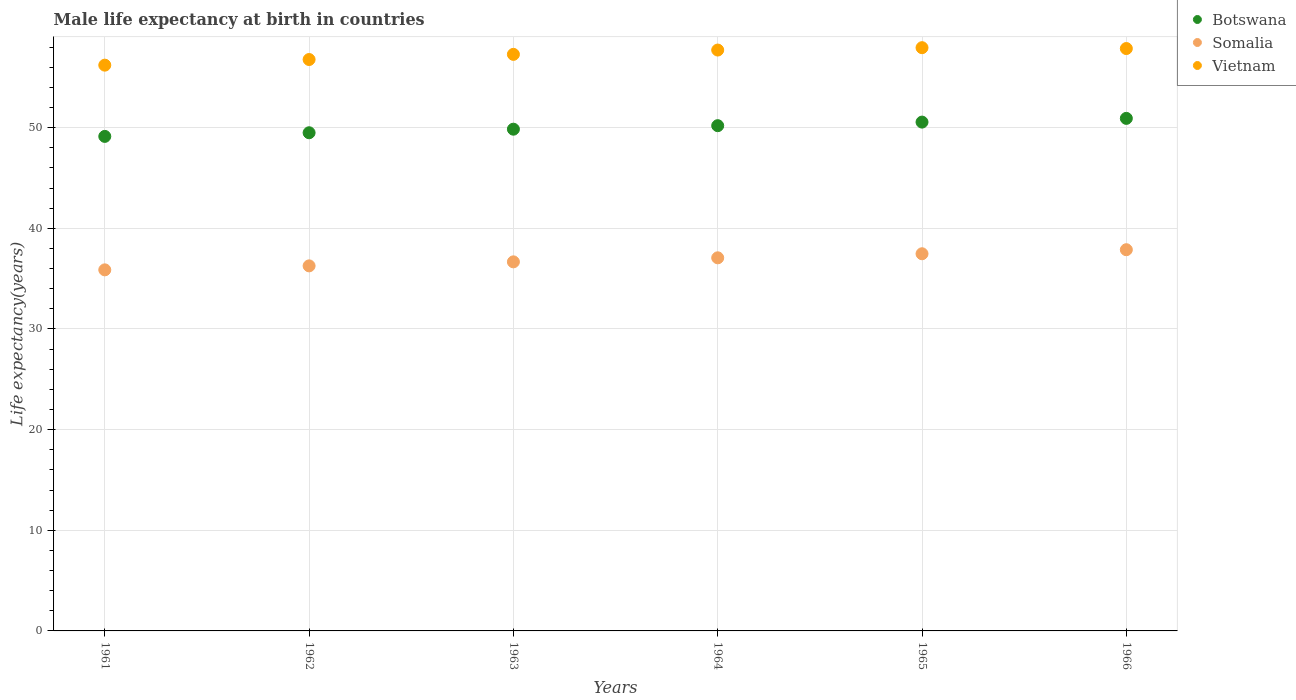What is the male life expectancy at birth in Vietnam in 1966?
Your answer should be very brief. 57.86. Across all years, what is the maximum male life expectancy at birth in Vietnam?
Provide a short and direct response. 57.95. Across all years, what is the minimum male life expectancy at birth in Vietnam?
Provide a succinct answer. 56.21. In which year was the male life expectancy at birth in Somalia maximum?
Provide a short and direct response. 1966. In which year was the male life expectancy at birth in Vietnam minimum?
Your answer should be compact. 1961. What is the total male life expectancy at birth in Somalia in the graph?
Provide a short and direct response. 221.23. What is the difference between the male life expectancy at birth in Somalia in 1961 and that in 1962?
Your answer should be very brief. -0.4. What is the difference between the male life expectancy at birth in Botswana in 1966 and the male life expectancy at birth in Vietnam in 1964?
Provide a succinct answer. -6.79. What is the average male life expectancy at birth in Botswana per year?
Give a very brief answer. 50.03. In the year 1963, what is the difference between the male life expectancy at birth in Vietnam and male life expectancy at birth in Somalia?
Provide a short and direct response. 20.62. What is the ratio of the male life expectancy at birth in Botswana in 1963 to that in 1966?
Make the answer very short. 0.98. Is the male life expectancy at birth in Somalia in 1964 less than that in 1966?
Give a very brief answer. Yes. What is the difference between the highest and the second highest male life expectancy at birth in Vietnam?
Offer a very short reply. 0.09. What is the difference between the highest and the lowest male life expectancy at birth in Vietnam?
Offer a very short reply. 1.74. In how many years, is the male life expectancy at birth in Somalia greater than the average male life expectancy at birth in Somalia taken over all years?
Provide a short and direct response. 3. Is it the case that in every year, the sum of the male life expectancy at birth in Botswana and male life expectancy at birth in Somalia  is greater than the male life expectancy at birth in Vietnam?
Provide a succinct answer. Yes. Does the male life expectancy at birth in Vietnam monotonically increase over the years?
Make the answer very short. No. Are the values on the major ticks of Y-axis written in scientific E-notation?
Provide a short and direct response. No. How are the legend labels stacked?
Offer a very short reply. Vertical. What is the title of the graph?
Your answer should be compact. Male life expectancy at birth in countries. What is the label or title of the X-axis?
Your answer should be very brief. Years. What is the label or title of the Y-axis?
Provide a short and direct response. Life expectancy(years). What is the Life expectancy(years) in Botswana in 1961?
Ensure brevity in your answer.  49.13. What is the Life expectancy(years) of Somalia in 1961?
Provide a succinct answer. 35.87. What is the Life expectancy(years) in Vietnam in 1961?
Give a very brief answer. 56.21. What is the Life expectancy(years) of Botswana in 1962?
Make the answer very short. 49.5. What is the Life expectancy(years) of Somalia in 1962?
Provide a short and direct response. 36.27. What is the Life expectancy(years) in Vietnam in 1962?
Your answer should be very brief. 56.77. What is the Life expectancy(years) in Botswana in 1963?
Ensure brevity in your answer.  49.85. What is the Life expectancy(years) in Somalia in 1963?
Make the answer very short. 36.67. What is the Life expectancy(years) in Vietnam in 1963?
Ensure brevity in your answer.  57.28. What is the Life expectancy(years) of Botswana in 1964?
Offer a terse response. 50.2. What is the Life expectancy(years) of Somalia in 1964?
Offer a very short reply. 37.07. What is the Life expectancy(years) of Vietnam in 1964?
Make the answer very short. 57.71. What is the Life expectancy(years) of Botswana in 1965?
Keep it short and to the point. 50.55. What is the Life expectancy(years) of Somalia in 1965?
Offer a terse response. 37.47. What is the Life expectancy(years) of Vietnam in 1965?
Your answer should be compact. 57.95. What is the Life expectancy(years) of Botswana in 1966?
Keep it short and to the point. 50.92. What is the Life expectancy(years) of Somalia in 1966?
Offer a very short reply. 37.88. What is the Life expectancy(years) of Vietnam in 1966?
Keep it short and to the point. 57.86. Across all years, what is the maximum Life expectancy(years) of Botswana?
Keep it short and to the point. 50.92. Across all years, what is the maximum Life expectancy(years) of Somalia?
Offer a very short reply. 37.88. Across all years, what is the maximum Life expectancy(years) of Vietnam?
Provide a succinct answer. 57.95. Across all years, what is the minimum Life expectancy(years) of Botswana?
Make the answer very short. 49.13. Across all years, what is the minimum Life expectancy(years) in Somalia?
Your answer should be very brief. 35.87. Across all years, what is the minimum Life expectancy(years) of Vietnam?
Ensure brevity in your answer.  56.21. What is the total Life expectancy(years) of Botswana in the graph?
Offer a terse response. 300.16. What is the total Life expectancy(years) in Somalia in the graph?
Your answer should be very brief. 221.23. What is the total Life expectancy(years) in Vietnam in the graph?
Ensure brevity in your answer.  343.79. What is the difference between the Life expectancy(years) of Botswana in 1961 and that in 1962?
Your answer should be very brief. -0.36. What is the difference between the Life expectancy(years) in Somalia in 1961 and that in 1962?
Keep it short and to the point. -0.4. What is the difference between the Life expectancy(years) in Vietnam in 1961 and that in 1962?
Provide a succinct answer. -0.56. What is the difference between the Life expectancy(years) of Botswana in 1961 and that in 1963?
Make the answer very short. -0.72. What is the difference between the Life expectancy(years) of Somalia in 1961 and that in 1963?
Ensure brevity in your answer.  -0.8. What is the difference between the Life expectancy(years) in Vietnam in 1961 and that in 1963?
Offer a very short reply. -1.07. What is the difference between the Life expectancy(years) of Botswana in 1961 and that in 1964?
Offer a very short reply. -1.07. What is the difference between the Life expectancy(years) of Somalia in 1961 and that in 1964?
Make the answer very short. -1.2. What is the difference between the Life expectancy(years) of Vietnam in 1961 and that in 1964?
Your answer should be very brief. -1.5. What is the difference between the Life expectancy(years) in Botswana in 1961 and that in 1965?
Give a very brief answer. -1.42. What is the difference between the Life expectancy(years) in Somalia in 1961 and that in 1965?
Ensure brevity in your answer.  -1.6. What is the difference between the Life expectancy(years) in Vietnam in 1961 and that in 1965?
Provide a short and direct response. -1.74. What is the difference between the Life expectancy(years) in Botswana in 1961 and that in 1966?
Your answer should be very brief. -1.79. What is the difference between the Life expectancy(years) of Somalia in 1961 and that in 1966?
Provide a short and direct response. -2. What is the difference between the Life expectancy(years) of Vietnam in 1961 and that in 1966?
Provide a short and direct response. -1.65. What is the difference between the Life expectancy(years) in Botswana in 1962 and that in 1963?
Your answer should be very brief. -0.35. What is the difference between the Life expectancy(years) of Somalia in 1962 and that in 1963?
Make the answer very short. -0.4. What is the difference between the Life expectancy(years) in Vietnam in 1962 and that in 1963?
Offer a very short reply. -0.51. What is the difference between the Life expectancy(years) in Botswana in 1962 and that in 1964?
Your response must be concise. -0.7. What is the difference between the Life expectancy(years) in Vietnam in 1962 and that in 1964?
Ensure brevity in your answer.  -0.94. What is the difference between the Life expectancy(years) of Botswana in 1962 and that in 1965?
Your answer should be compact. -1.06. What is the difference between the Life expectancy(years) of Somalia in 1962 and that in 1965?
Your response must be concise. -1.2. What is the difference between the Life expectancy(years) of Vietnam in 1962 and that in 1965?
Your answer should be compact. -1.18. What is the difference between the Life expectancy(years) of Botswana in 1962 and that in 1966?
Give a very brief answer. -1.43. What is the difference between the Life expectancy(years) in Somalia in 1962 and that in 1966?
Provide a short and direct response. -1.6. What is the difference between the Life expectancy(years) of Vietnam in 1962 and that in 1966?
Provide a short and direct response. -1.09. What is the difference between the Life expectancy(years) in Botswana in 1963 and that in 1964?
Give a very brief answer. -0.35. What is the difference between the Life expectancy(years) in Somalia in 1963 and that in 1964?
Provide a short and direct response. -0.4. What is the difference between the Life expectancy(years) of Vietnam in 1963 and that in 1964?
Provide a succinct answer. -0.43. What is the difference between the Life expectancy(years) in Botswana in 1963 and that in 1965?
Offer a very short reply. -0.7. What is the difference between the Life expectancy(years) of Somalia in 1963 and that in 1965?
Your response must be concise. -0.8. What is the difference between the Life expectancy(years) in Vietnam in 1963 and that in 1965?
Provide a succinct answer. -0.66. What is the difference between the Life expectancy(years) in Botswana in 1963 and that in 1966?
Your answer should be compact. -1.07. What is the difference between the Life expectancy(years) of Somalia in 1963 and that in 1966?
Ensure brevity in your answer.  -1.21. What is the difference between the Life expectancy(years) in Vietnam in 1963 and that in 1966?
Offer a very short reply. -0.58. What is the difference between the Life expectancy(years) of Botswana in 1964 and that in 1965?
Offer a terse response. -0.35. What is the difference between the Life expectancy(years) in Somalia in 1964 and that in 1965?
Provide a short and direct response. -0.4. What is the difference between the Life expectancy(years) of Vietnam in 1964 and that in 1965?
Provide a succinct answer. -0.23. What is the difference between the Life expectancy(years) of Botswana in 1964 and that in 1966?
Your answer should be very brief. -0.72. What is the difference between the Life expectancy(years) of Somalia in 1964 and that in 1966?
Keep it short and to the point. -0.81. What is the difference between the Life expectancy(years) of Botswana in 1965 and that in 1966?
Your answer should be very brief. -0.37. What is the difference between the Life expectancy(years) of Somalia in 1965 and that in 1966?
Keep it short and to the point. -0.4. What is the difference between the Life expectancy(years) of Vietnam in 1965 and that in 1966?
Provide a short and direct response. 0.09. What is the difference between the Life expectancy(years) of Botswana in 1961 and the Life expectancy(years) of Somalia in 1962?
Keep it short and to the point. 12.86. What is the difference between the Life expectancy(years) of Botswana in 1961 and the Life expectancy(years) of Vietnam in 1962?
Offer a terse response. -7.64. What is the difference between the Life expectancy(years) in Somalia in 1961 and the Life expectancy(years) in Vietnam in 1962?
Offer a terse response. -20.9. What is the difference between the Life expectancy(years) in Botswana in 1961 and the Life expectancy(years) in Somalia in 1963?
Make the answer very short. 12.46. What is the difference between the Life expectancy(years) of Botswana in 1961 and the Life expectancy(years) of Vietnam in 1963?
Your answer should be very brief. -8.15. What is the difference between the Life expectancy(years) in Somalia in 1961 and the Life expectancy(years) in Vietnam in 1963?
Ensure brevity in your answer.  -21.41. What is the difference between the Life expectancy(years) in Botswana in 1961 and the Life expectancy(years) in Somalia in 1964?
Keep it short and to the point. 12.06. What is the difference between the Life expectancy(years) of Botswana in 1961 and the Life expectancy(years) of Vietnam in 1964?
Your response must be concise. -8.58. What is the difference between the Life expectancy(years) in Somalia in 1961 and the Life expectancy(years) in Vietnam in 1964?
Offer a terse response. -21.84. What is the difference between the Life expectancy(years) in Botswana in 1961 and the Life expectancy(years) in Somalia in 1965?
Your answer should be very brief. 11.66. What is the difference between the Life expectancy(years) in Botswana in 1961 and the Life expectancy(years) in Vietnam in 1965?
Your answer should be very brief. -8.81. What is the difference between the Life expectancy(years) in Somalia in 1961 and the Life expectancy(years) in Vietnam in 1965?
Your response must be concise. -22.07. What is the difference between the Life expectancy(years) of Botswana in 1961 and the Life expectancy(years) of Somalia in 1966?
Offer a very short reply. 11.26. What is the difference between the Life expectancy(years) of Botswana in 1961 and the Life expectancy(years) of Vietnam in 1966?
Your answer should be very brief. -8.73. What is the difference between the Life expectancy(years) of Somalia in 1961 and the Life expectancy(years) of Vietnam in 1966?
Provide a succinct answer. -21.99. What is the difference between the Life expectancy(years) of Botswana in 1962 and the Life expectancy(years) of Somalia in 1963?
Make the answer very short. 12.83. What is the difference between the Life expectancy(years) in Botswana in 1962 and the Life expectancy(years) in Vietnam in 1963?
Your response must be concise. -7.79. What is the difference between the Life expectancy(years) of Somalia in 1962 and the Life expectancy(years) of Vietnam in 1963?
Offer a terse response. -21.01. What is the difference between the Life expectancy(years) in Botswana in 1962 and the Life expectancy(years) in Somalia in 1964?
Your answer should be very brief. 12.43. What is the difference between the Life expectancy(years) of Botswana in 1962 and the Life expectancy(years) of Vietnam in 1964?
Keep it short and to the point. -8.22. What is the difference between the Life expectancy(years) of Somalia in 1962 and the Life expectancy(years) of Vietnam in 1964?
Provide a succinct answer. -21.44. What is the difference between the Life expectancy(years) in Botswana in 1962 and the Life expectancy(years) in Somalia in 1965?
Provide a succinct answer. 12.02. What is the difference between the Life expectancy(years) in Botswana in 1962 and the Life expectancy(years) in Vietnam in 1965?
Offer a very short reply. -8.45. What is the difference between the Life expectancy(years) of Somalia in 1962 and the Life expectancy(years) of Vietnam in 1965?
Offer a very short reply. -21.68. What is the difference between the Life expectancy(years) in Botswana in 1962 and the Life expectancy(years) in Somalia in 1966?
Make the answer very short. 11.62. What is the difference between the Life expectancy(years) in Botswana in 1962 and the Life expectancy(years) in Vietnam in 1966?
Provide a succinct answer. -8.37. What is the difference between the Life expectancy(years) of Somalia in 1962 and the Life expectancy(years) of Vietnam in 1966?
Your answer should be very brief. -21.59. What is the difference between the Life expectancy(years) in Botswana in 1963 and the Life expectancy(years) in Somalia in 1964?
Your answer should be very brief. 12.78. What is the difference between the Life expectancy(years) in Botswana in 1963 and the Life expectancy(years) in Vietnam in 1964?
Ensure brevity in your answer.  -7.86. What is the difference between the Life expectancy(years) in Somalia in 1963 and the Life expectancy(years) in Vietnam in 1964?
Provide a short and direct response. -21.04. What is the difference between the Life expectancy(years) in Botswana in 1963 and the Life expectancy(years) in Somalia in 1965?
Offer a terse response. 12.38. What is the difference between the Life expectancy(years) in Botswana in 1963 and the Life expectancy(years) in Vietnam in 1965?
Provide a short and direct response. -8.1. What is the difference between the Life expectancy(years) of Somalia in 1963 and the Life expectancy(years) of Vietnam in 1965?
Your response must be concise. -21.28. What is the difference between the Life expectancy(years) of Botswana in 1963 and the Life expectancy(years) of Somalia in 1966?
Offer a terse response. 11.97. What is the difference between the Life expectancy(years) in Botswana in 1963 and the Life expectancy(years) in Vietnam in 1966?
Your answer should be compact. -8.01. What is the difference between the Life expectancy(years) in Somalia in 1963 and the Life expectancy(years) in Vietnam in 1966?
Ensure brevity in your answer.  -21.19. What is the difference between the Life expectancy(years) of Botswana in 1964 and the Life expectancy(years) of Somalia in 1965?
Your response must be concise. 12.73. What is the difference between the Life expectancy(years) in Botswana in 1964 and the Life expectancy(years) in Vietnam in 1965?
Give a very brief answer. -7.75. What is the difference between the Life expectancy(years) in Somalia in 1964 and the Life expectancy(years) in Vietnam in 1965?
Ensure brevity in your answer.  -20.88. What is the difference between the Life expectancy(years) of Botswana in 1964 and the Life expectancy(years) of Somalia in 1966?
Ensure brevity in your answer.  12.32. What is the difference between the Life expectancy(years) of Botswana in 1964 and the Life expectancy(years) of Vietnam in 1966?
Provide a succinct answer. -7.66. What is the difference between the Life expectancy(years) in Somalia in 1964 and the Life expectancy(years) in Vietnam in 1966?
Your answer should be very brief. -20.79. What is the difference between the Life expectancy(years) of Botswana in 1965 and the Life expectancy(years) of Somalia in 1966?
Give a very brief answer. 12.68. What is the difference between the Life expectancy(years) of Botswana in 1965 and the Life expectancy(years) of Vietnam in 1966?
Your response must be concise. -7.31. What is the difference between the Life expectancy(years) in Somalia in 1965 and the Life expectancy(years) in Vietnam in 1966?
Provide a succinct answer. -20.39. What is the average Life expectancy(years) of Botswana per year?
Ensure brevity in your answer.  50.03. What is the average Life expectancy(years) in Somalia per year?
Make the answer very short. 36.87. What is the average Life expectancy(years) of Vietnam per year?
Your answer should be compact. 57.3. In the year 1961, what is the difference between the Life expectancy(years) of Botswana and Life expectancy(years) of Somalia?
Give a very brief answer. 13.26. In the year 1961, what is the difference between the Life expectancy(years) in Botswana and Life expectancy(years) in Vietnam?
Your response must be concise. -7.08. In the year 1961, what is the difference between the Life expectancy(years) of Somalia and Life expectancy(years) of Vietnam?
Ensure brevity in your answer.  -20.34. In the year 1962, what is the difference between the Life expectancy(years) in Botswana and Life expectancy(years) in Somalia?
Your answer should be compact. 13.23. In the year 1962, what is the difference between the Life expectancy(years) of Botswana and Life expectancy(years) of Vietnam?
Keep it short and to the point. -7.28. In the year 1962, what is the difference between the Life expectancy(years) of Somalia and Life expectancy(years) of Vietnam?
Your response must be concise. -20.5. In the year 1963, what is the difference between the Life expectancy(years) in Botswana and Life expectancy(years) in Somalia?
Keep it short and to the point. 13.18. In the year 1963, what is the difference between the Life expectancy(years) in Botswana and Life expectancy(years) in Vietnam?
Keep it short and to the point. -7.43. In the year 1963, what is the difference between the Life expectancy(years) in Somalia and Life expectancy(years) in Vietnam?
Ensure brevity in your answer.  -20.61. In the year 1964, what is the difference between the Life expectancy(years) in Botswana and Life expectancy(years) in Somalia?
Ensure brevity in your answer.  13.13. In the year 1964, what is the difference between the Life expectancy(years) in Botswana and Life expectancy(years) in Vietnam?
Provide a succinct answer. -7.51. In the year 1964, what is the difference between the Life expectancy(years) of Somalia and Life expectancy(years) of Vietnam?
Give a very brief answer. -20.64. In the year 1965, what is the difference between the Life expectancy(years) of Botswana and Life expectancy(years) of Somalia?
Ensure brevity in your answer.  13.08. In the year 1965, what is the difference between the Life expectancy(years) in Botswana and Life expectancy(years) in Vietnam?
Give a very brief answer. -7.39. In the year 1965, what is the difference between the Life expectancy(years) in Somalia and Life expectancy(years) in Vietnam?
Make the answer very short. -20.48. In the year 1966, what is the difference between the Life expectancy(years) of Botswana and Life expectancy(years) of Somalia?
Make the answer very short. 13.05. In the year 1966, what is the difference between the Life expectancy(years) in Botswana and Life expectancy(years) in Vietnam?
Your answer should be compact. -6.94. In the year 1966, what is the difference between the Life expectancy(years) of Somalia and Life expectancy(years) of Vietnam?
Offer a terse response. -19.99. What is the ratio of the Life expectancy(years) of Botswana in 1961 to that in 1962?
Provide a succinct answer. 0.99. What is the ratio of the Life expectancy(years) in Botswana in 1961 to that in 1963?
Provide a short and direct response. 0.99. What is the ratio of the Life expectancy(years) in Somalia in 1961 to that in 1963?
Offer a terse response. 0.98. What is the ratio of the Life expectancy(years) of Vietnam in 1961 to that in 1963?
Give a very brief answer. 0.98. What is the ratio of the Life expectancy(years) of Botswana in 1961 to that in 1964?
Your answer should be compact. 0.98. What is the ratio of the Life expectancy(years) in Vietnam in 1961 to that in 1964?
Keep it short and to the point. 0.97. What is the ratio of the Life expectancy(years) of Botswana in 1961 to that in 1965?
Ensure brevity in your answer.  0.97. What is the ratio of the Life expectancy(years) in Somalia in 1961 to that in 1965?
Your answer should be compact. 0.96. What is the ratio of the Life expectancy(years) in Vietnam in 1961 to that in 1965?
Offer a very short reply. 0.97. What is the ratio of the Life expectancy(years) of Botswana in 1961 to that in 1966?
Provide a succinct answer. 0.96. What is the ratio of the Life expectancy(years) in Somalia in 1961 to that in 1966?
Ensure brevity in your answer.  0.95. What is the ratio of the Life expectancy(years) of Vietnam in 1961 to that in 1966?
Give a very brief answer. 0.97. What is the ratio of the Life expectancy(years) of Somalia in 1962 to that in 1963?
Give a very brief answer. 0.99. What is the ratio of the Life expectancy(years) of Somalia in 1962 to that in 1964?
Offer a very short reply. 0.98. What is the ratio of the Life expectancy(years) in Vietnam in 1962 to that in 1964?
Provide a succinct answer. 0.98. What is the ratio of the Life expectancy(years) in Botswana in 1962 to that in 1965?
Give a very brief answer. 0.98. What is the ratio of the Life expectancy(years) in Somalia in 1962 to that in 1965?
Make the answer very short. 0.97. What is the ratio of the Life expectancy(years) in Vietnam in 1962 to that in 1965?
Provide a succinct answer. 0.98. What is the ratio of the Life expectancy(years) of Botswana in 1962 to that in 1966?
Provide a succinct answer. 0.97. What is the ratio of the Life expectancy(years) in Somalia in 1962 to that in 1966?
Make the answer very short. 0.96. What is the ratio of the Life expectancy(years) of Vietnam in 1962 to that in 1966?
Ensure brevity in your answer.  0.98. What is the ratio of the Life expectancy(years) of Somalia in 1963 to that in 1964?
Offer a very short reply. 0.99. What is the ratio of the Life expectancy(years) of Vietnam in 1963 to that in 1964?
Make the answer very short. 0.99. What is the ratio of the Life expectancy(years) of Botswana in 1963 to that in 1965?
Make the answer very short. 0.99. What is the ratio of the Life expectancy(years) of Somalia in 1963 to that in 1965?
Make the answer very short. 0.98. What is the ratio of the Life expectancy(years) in Botswana in 1963 to that in 1966?
Make the answer very short. 0.98. What is the ratio of the Life expectancy(years) of Somalia in 1963 to that in 1966?
Your answer should be compact. 0.97. What is the ratio of the Life expectancy(years) in Somalia in 1964 to that in 1965?
Give a very brief answer. 0.99. What is the ratio of the Life expectancy(years) of Vietnam in 1964 to that in 1965?
Ensure brevity in your answer.  1. What is the ratio of the Life expectancy(years) in Botswana in 1964 to that in 1966?
Provide a succinct answer. 0.99. What is the ratio of the Life expectancy(years) of Somalia in 1964 to that in 1966?
Your response must be concise. 0.98. What is the ratio of the Life expectancy(years) in Botswana in 1965 to that in 1966?
Offer a terse response. 0.99. What is the ratio of the Life expectancy(years) of Somalia in 1965 to that in 1966?
Make the answer very short. 0.99. What is the difference between the highest and the second highest Life expectancy(years) in Botswana?
Give a very brief answer. 0.37. What is the difference between the highest and the second highest Life expectancy(years) of Somalia?
Your answer should be compact. 0.4. What is the difference between the highest and the second highest Life expectancy(years) in Vietnam?
Provide a short and direct response. 0.09. What is the difference between the highest and the lowest Life expectancy(years) in Botswana?
Your answer should be very brief. 1.79. What is the difference between the highest and the lowest Life expectancy(years) of Somalia?
Ensure brevity in your answer.  2. What is the difference between the highest and the lowest Life expectancy(years) of Vietnam?
Your answer should be compact. 1.74. 